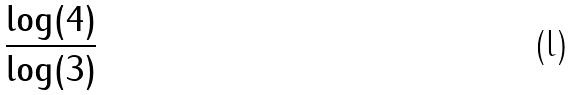<formula> <loc_0><loc_0><loc_500><loc_500>\frac { \log ( 4 ) } { \log ( 3 ) }</formula> 